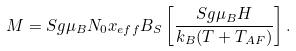<formula> <loc_0><loc_0><loc_500><loc_500>M = S g \mu _ { B } N _ { 0 } x _ { e f f } B _ { S } \left [ \frac { S g \mu _ { B } H } { k _ { B } ( T + T _ { A F } ) } \right ] .</formula> 